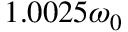Convert formula to latex. <formula><loc_0><loc_0><loc_500><loc_500>1 . 0 0 2 5 \omega _ { 0 }</formula> 